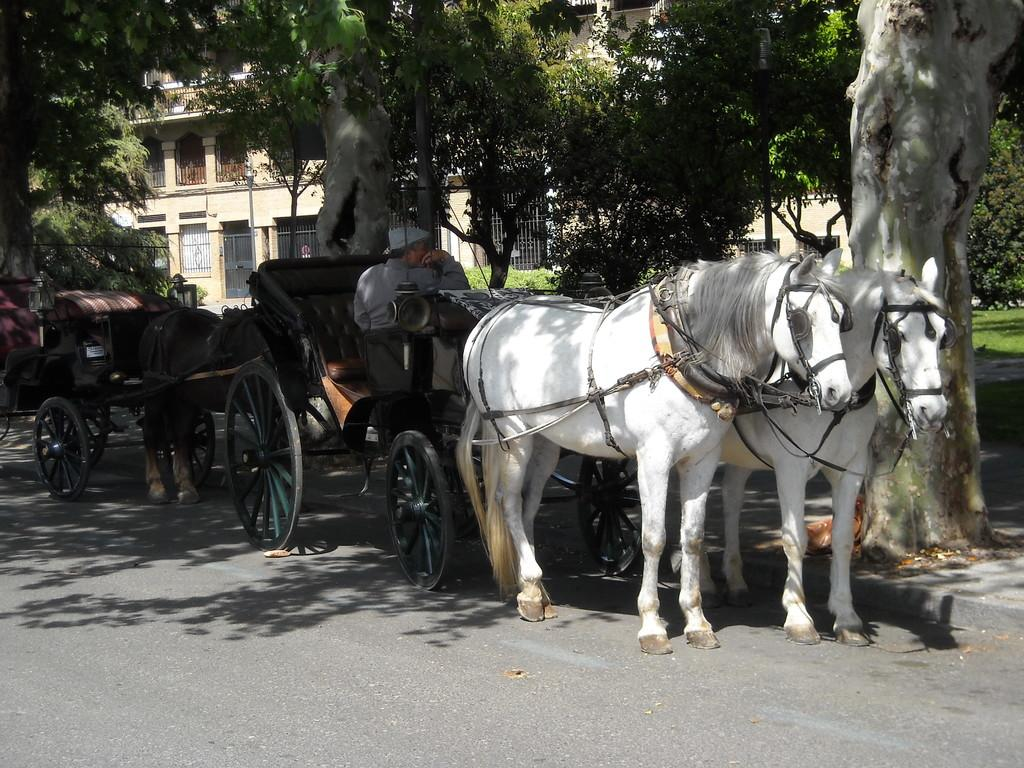What type of vehicles are in the image? There are carts in the image. What is pulling the carts? There are horses in the image that are pulling the carts. Where are the carts and horses located? The carts and horses are on a road in the image. Can you describe the background of the image? The background of the image includes plants, trees, grass, a building, and some unspecified objects. Who is present in the image? There is a person in the image. What does the bell sound like in the image? There is no bell present in the image. What is the caption of the image? The image does not have a caption; it is a visual representation without accompanying text. 